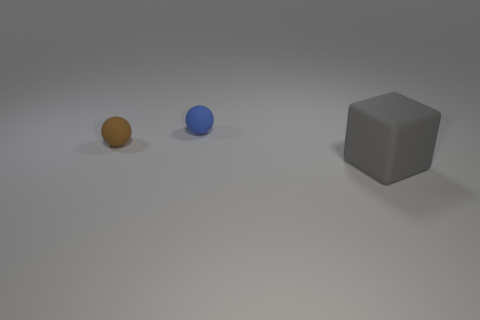Add 2 gray cubes. How many objects exist? 5 Subtract all blocks. How many objects are left? 2 Add 2 big gray matte blocks. How many big gray matte blocks exist? 3 Subtract 0 green balls. How many objects are left? 3 Subtract all cyan balls. Subtract all brown blocks. How many balls are left? 2 Subtract all gray cylinders. How many brown balls are left? 1 Subtract all large green shiny balls. Subtract all gray rubber things. How many objects are left? 2 Add 1 blue matte balls. How many blue matte balls are left? 2 